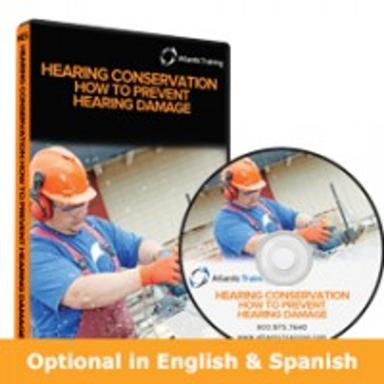What specific settings or industries might benefit from this DVD? Industries such as construction, manufacturing, and aviation that regularly expose workers to high decibel environments would highly benefit from this DVD. It provides crucial information on protecting workers' hearing, which is vital in maintaining overall health and work efficiency. 